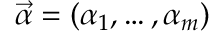Convert formula to latex. <formula><loc_0><loc_0><loc_500><loc_500>\vec { \alpha } = ( \alpha _ { 1 } , \dots , \alpha _ { m } )</formula> 